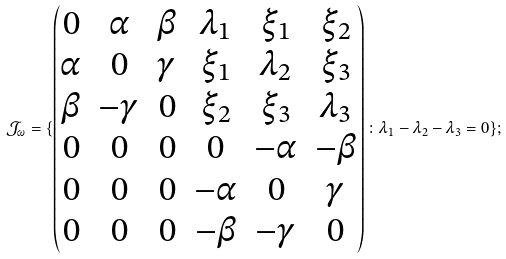<formula> <loc_0><loc_0><loc_500><loc_500>\mathcal { J } _ { \omega } = \{ \begin{pmatrix} 0 & \alpha & \beta & \lambda _ { 1 } & \xi _ { 1 } & \xi _ { 2 } \\ \alpha & 0 & \gamma & \xi _ { 1 } & \lambda _ { 2 } & \xi _ { 3 } \\ \beta & - \gamma & 0 & \xi _ { 2 } & \xi _ { 3 } & \lambda _ { 3 } \\ 0 & 0 & 0 & 0 & - \alpha & - \beta \\ 0 & 0 & 0 & - \alpha & 0 & \gamma \\ 0 & 0 & 0 & - \beta & - \gamma & 0 \end{pmatrix} \colon \lambda _ { 1 } - \lambda _ { 2 } - \lambda _ { 3 } = 0 \} ;</formula> 